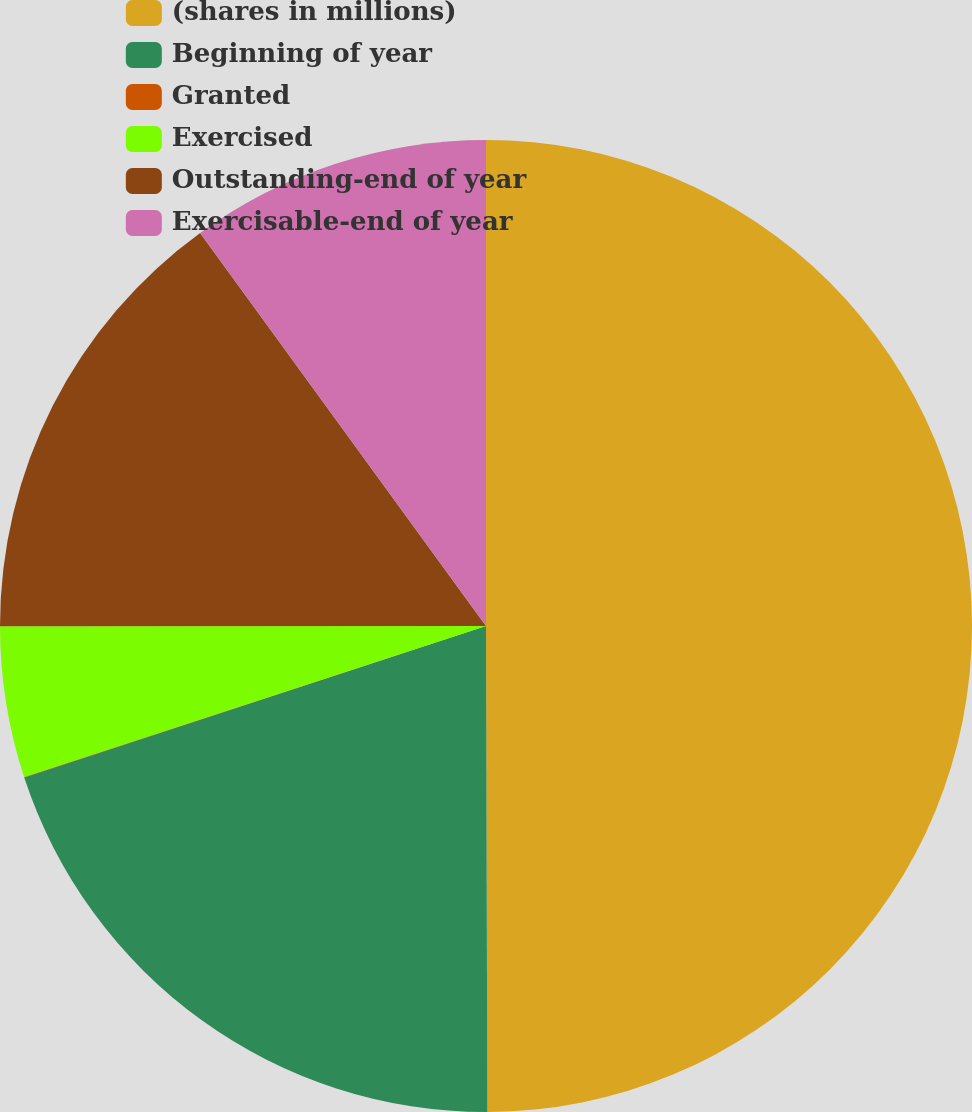<chart> <loc_0><loc_0><loc_500><loc_500><pie_chart><fcel>(shares in millions)<fcel>Beginning of year<fcel>Granted<fcel>Exercised<fcel>Outstanding-end of year<fcel>Exercisable-end of year<nl><fcel>49.96%<fcel>20.0%<fcel>0.02%<fcel>5.02%<fcel>15.0%<fcel>10.01%<nl></chart> 